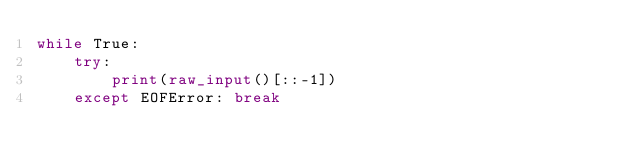Convert code to text. <code><loc_0><loc_0><loc_500><loc_500><_Python_>while True:
    try:
        print(raw_input()[::-1])
    except EOFError: break</code> 